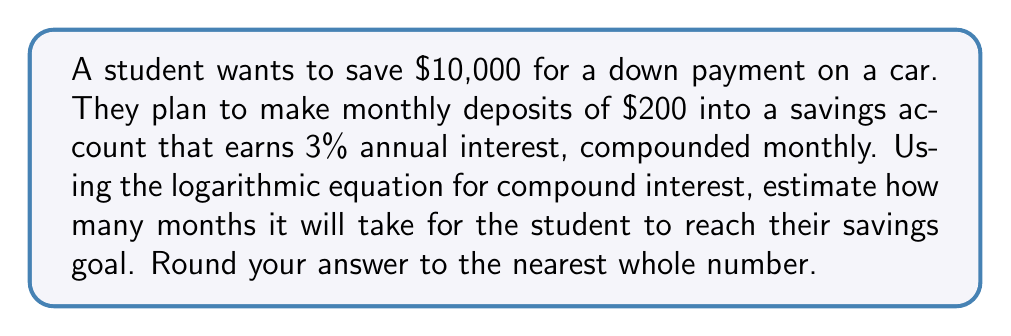Can you solve this math problem? Let's approach this step-by-step using the compound interest formula and logarithms:

1) The compound interest formula is:
   $$A = P(1 + \frac{r}{n})^{nt}$$
   Where:
   $A$ = final amount
   $P$ = principal (initial investment)
   $r$ = annual interest rate (as a decimal)
   $n$ = number of times interest is compounded per year
   $t$ = number of years

2) In this case:
   $A = 10000$ (goal)
   $P = 0$ (starting with no savings)
   $r = 0.03$ (3% annual interest)
   $n = 12$ (compounded monthly)
   $t = \frac{x}{12}$ (where $x$ is the number of months we're solving for)

3) We also need to account for the monthly deposits. Let's call the monthly deposit $d = 200$. The formula becomes:
   $$A = d\frac{(1 + \frac{r}{n})^{nt} - 1}{\frac{r}{n}}$$

4) Plugging in our values:
   $$10000 = 200\frac{(1 + \frac{0.03}{12})^{12(\frac{x}{12})} - 1}{\frac{0.03}{12}}$$

5) Simplify:
   $$10000 = 200\frac{(1.0025)^x - 1}{0.0025}$$

6) Multiply both sides by 0.0025:
   $$25 = 200((1.0025)^x - 1)$$

7) Divide by 200:
   $$0.125 = (1.0025)^x - 1$$

8) Add 1 to both sides:
   $$1.125 = (1.0025)^x$$

9) Take the natural log of both sides:
   $$\ln(1.125) = x\ln(1.0025)$$

10) Solve for $x$:
    $$x = \frac{\ln(1.125)}{\ln(1.0025)} \approx 47.57$$

11) Round to the nearest whole number:
    $x = 48$
Answer: 48 months 